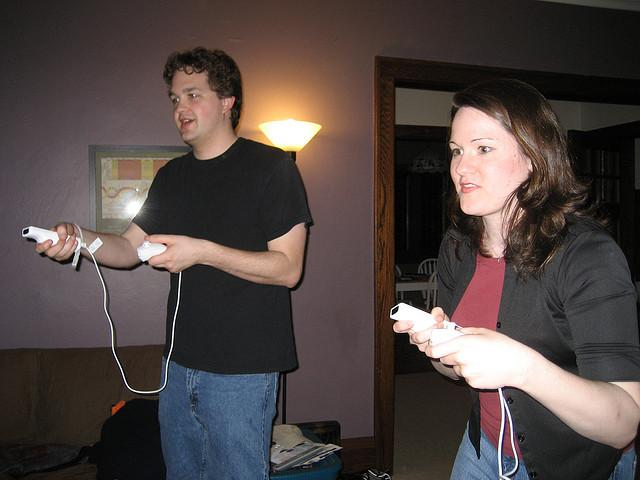What video game system are they playing? wii 